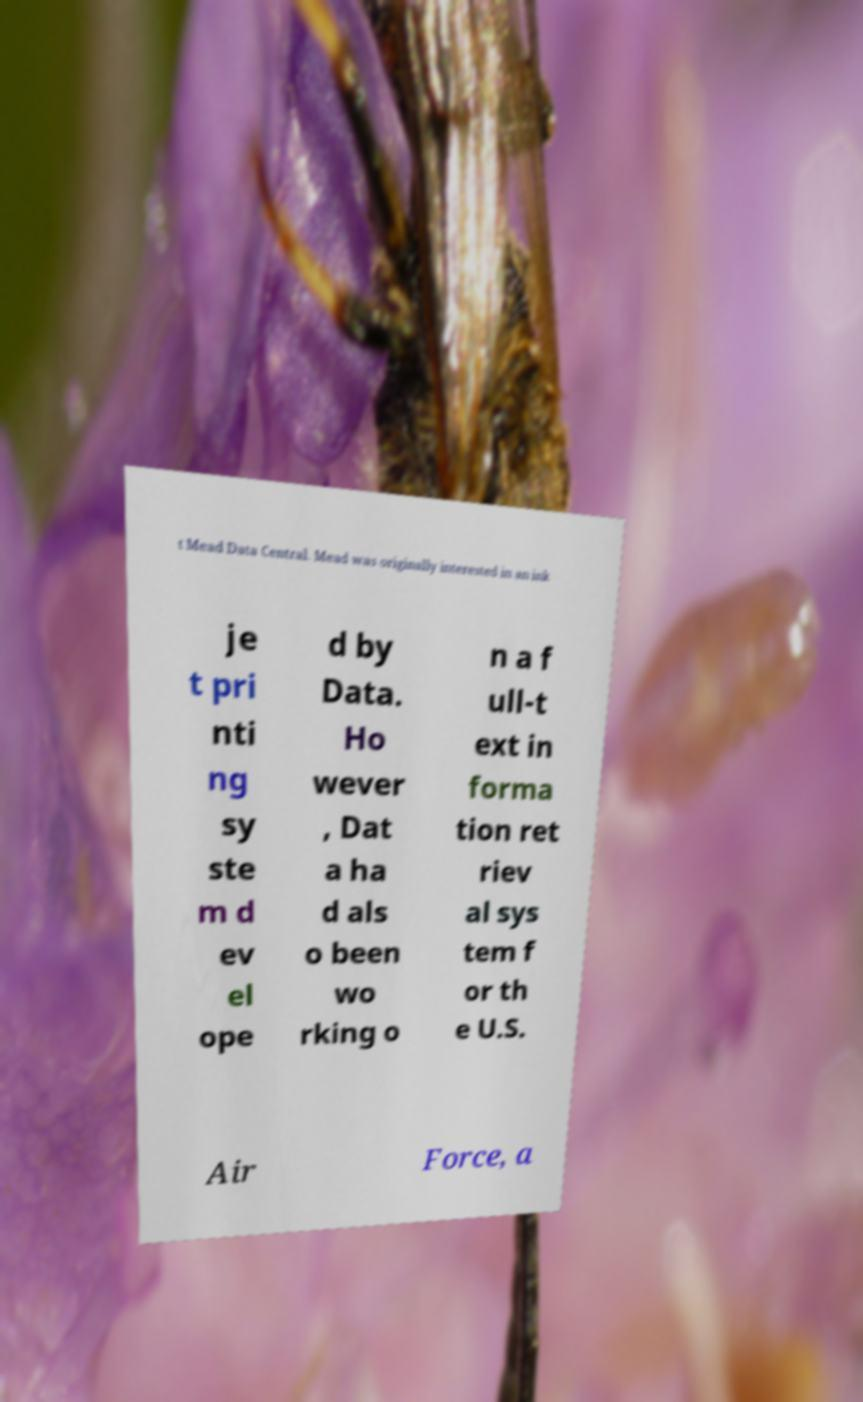I need the written content from this picture converted into text. Can you do that? t Mead Data Central. Mead was originally interested in an ink je t pri nti ng sy ste m d ev el ope d by Data. Ho wever , Dat a ha d als o been wo rking o n a f ull-t ext in forma tion ret riev al sys tem f or th e U.S. Air Force, a 